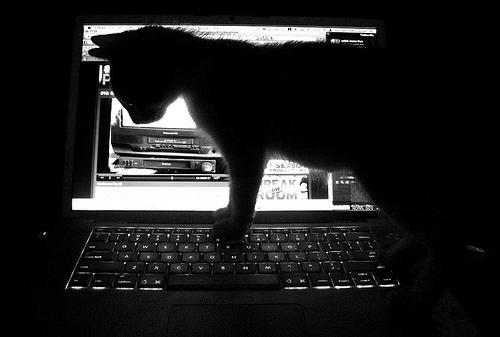Question: why is the computer brightly lit?
Choices:
A. The brightness is set high.
B. It's powered on.
C. There is a lamp on the table.
D. The light is on in the room.
Answer with the letter. Answer: B Question: what kind of animal is there?
Choices:
A. A dog.
B. A ferret.
C. A mouse.
D. A kitten.
Answer with the letter. Answer: D Question: who is with the cat?
Choices:
A. The dog.
B. No one.
C. The girl.
D. Another cat.
Answer with the letter. Answer: B Question: what colors are in the photo?
Choices:
A. Blue and red.
B. Orange and yellow.
C. Black and white.
D. Mauve and taupe.
Answer with the letter. Answer: C Question: where is the cat?
Choices:
A. On the table.
B. On the chair.
C. On the floor.
D. On the keyboard.
Answer with the letter. Answer: D 